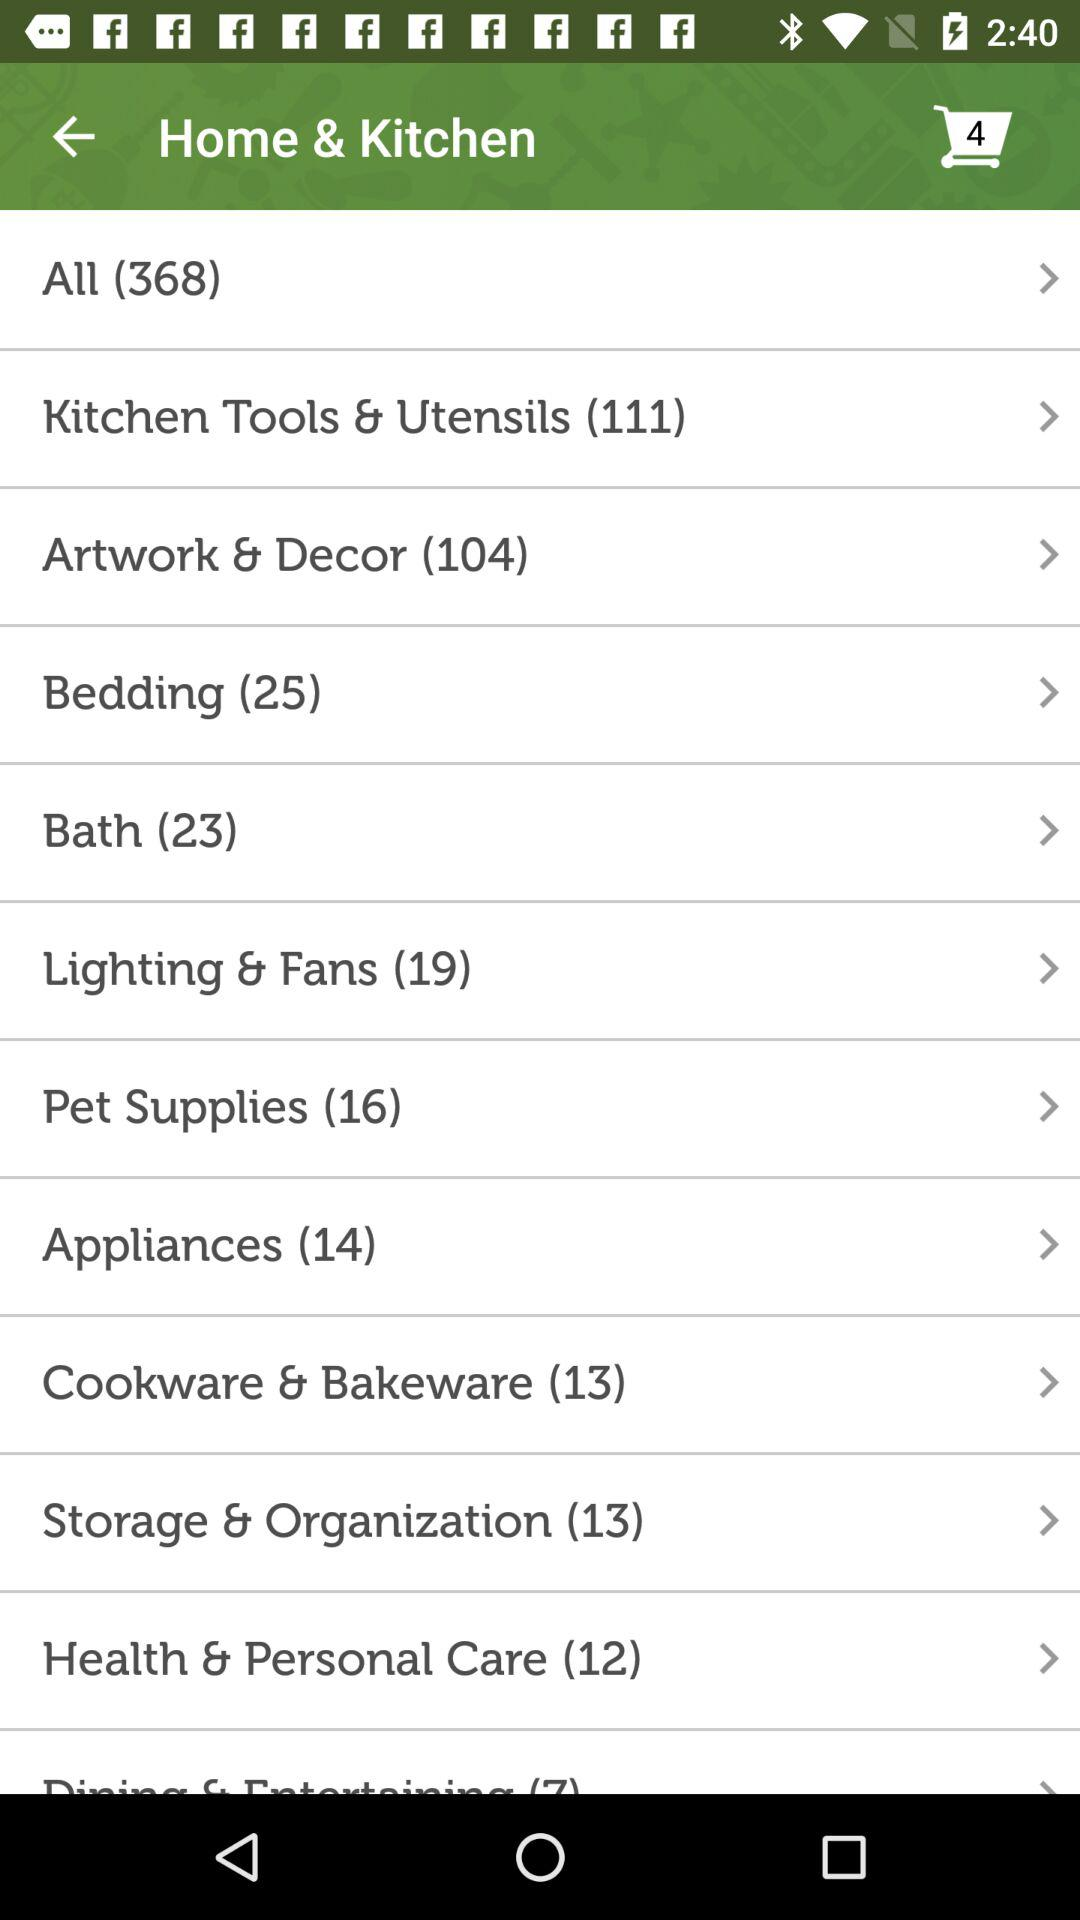How many items are added to the cart? The number of items added to the cart is 4. 